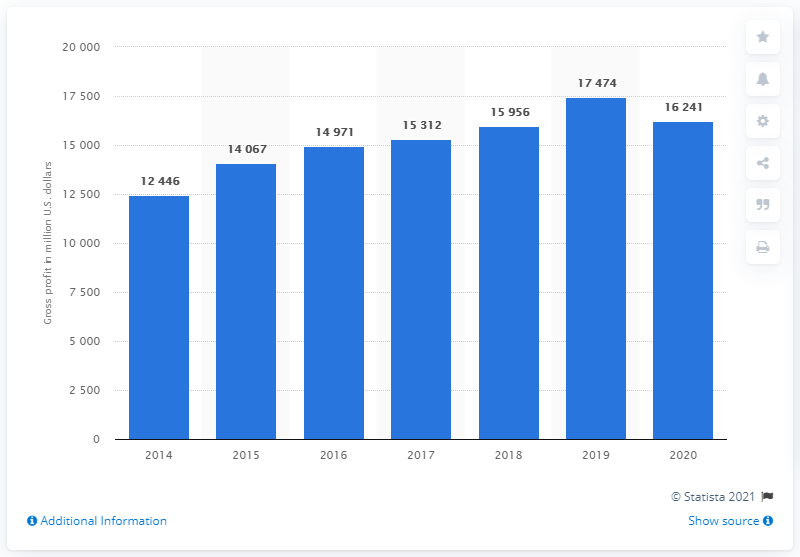Give some essential details in this illustration. In 2020, Nike's global gross profit was 16,241 million dollars. In 2014, Nike's global gross profit was 12,446 dollars. 